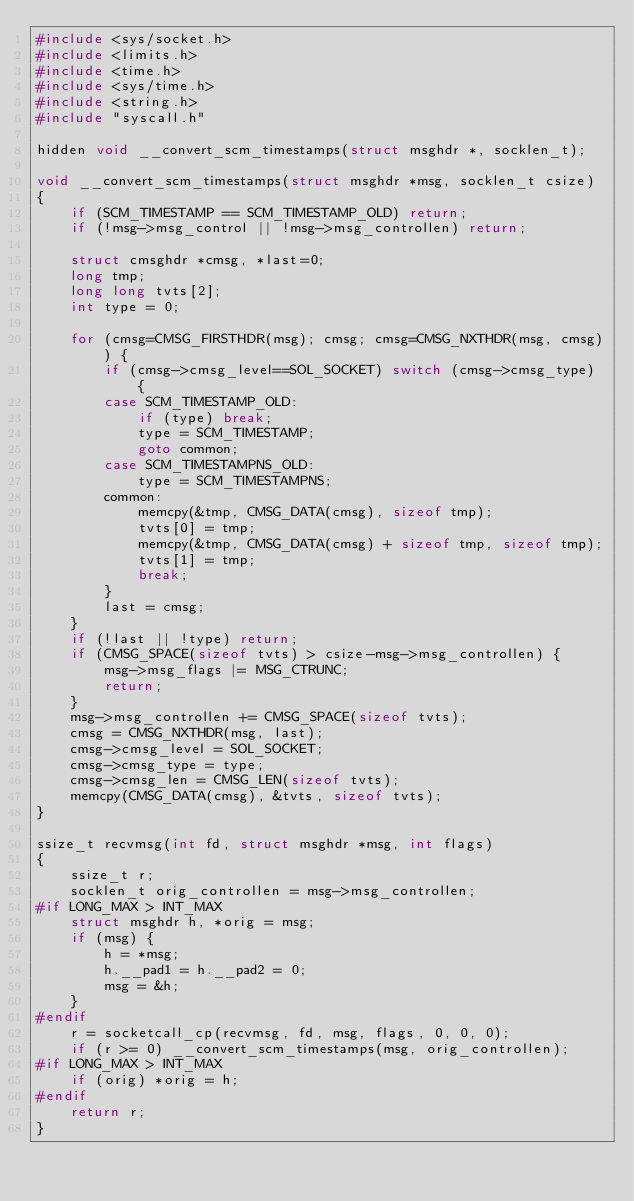<code> <loc_0><loc_0><loc_500><loc_500><_C_>#include <sys/socket.h>
#include <limits.h>
#include <time.h>
#include <sys/time.h>
#include <string.h>
#include "syscall.h"

hidden void __convert_scm_timestamps(struct msghdr *, socklen_t);

void __convert_scm_timestamps(struct msghdr *msg, socklen_t csize)
{
	if (SCM_TIMESTAMP == SCM_TIMESTAMP_OLD) return;
	if (!msg->msg_control || !msg->msg_controllen) return;

	struct cmsghdr *cmsg, *last=0;
	long tmp;
	long long tvts[2];
	int type = 0;

	for (cmsg=CMSG_FIRSTHDR(msg); cmsg; cmsg=CMSG_NXTHDR(msg, cmsg)) {
		if (cmsg->cmsg_level==SOL_SOCKET) switch (cmsg->cmsg_type) {
		case SCM_TIMESTAMP_OLD:
			if (type) break;
			type = SCM_TIMESTAMP;
			goto common;
		case SCM_TIMESTAMPNS_OLD:
			type = SCM_TIMESTAMPNS;
		common:
			memcpy(&tmp, CMSG_DATA(cmsg), sizeof tmp);
			tvts[0] = tmp;
			memcpy(&tmp, CMSG_DATA(cmsg) + sizeof tmp, sizeof tmp);
			tvts[1] = tmp;
			break;
		}
		last = cmsg;
	}
	if (!last || !type) return;
	if (CMSG_SPACE(sizeof tvts) > csize-msg->msg_controllen) {
		msg->msg_flags |= MSG_CTRUNC;
		return;
	}
	msg->msg_controllen += CMSG_SPACE(sizeof tvts);
	cmsg = CMSG_NXTHDR(msg, last);
	cmsg->cmsg_level = SOL_SOCKET;
	cmsg->cmsg_type = type;
	cmsg->cmsg_len = CMSG_LEN(sizeof tvts);
	memcpy(CMSG_DATA(cmsg), &tvts, sizeof tvts);
}

ssize_t recvmsg(int fd, struct msghdr *msg, int flags)
{
	ssize_t r;
	socklen_t orig_controllen = msg->msg_controllen;
#if LONG_MAX > INT_MAX
	struct msghdr h, *orig = msg;
	if (msg) {
		h = *msg;
		h.__pad1 = h.__pad2 = 0;
		msg = &h;
	}
#endif
	r = socketcall_cp(recvmsg, fd, msg, flags, 0, 0, 0);
	if (r >= 0) __convert_scm_timestamps(msg, orig_controllen);
#if LONG_MAX > INT_MAX
	if (orig) *orig = h;
#endif
	return r;
}
</code> 